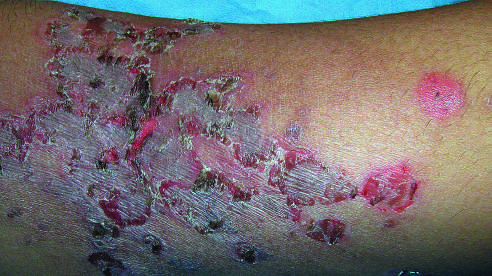what is a child 's arm involved by?
Answer the question using a single word or phrase. A superficial bacterial infection showing the characteristic erythematous scablike lesions crusted with dried serum 